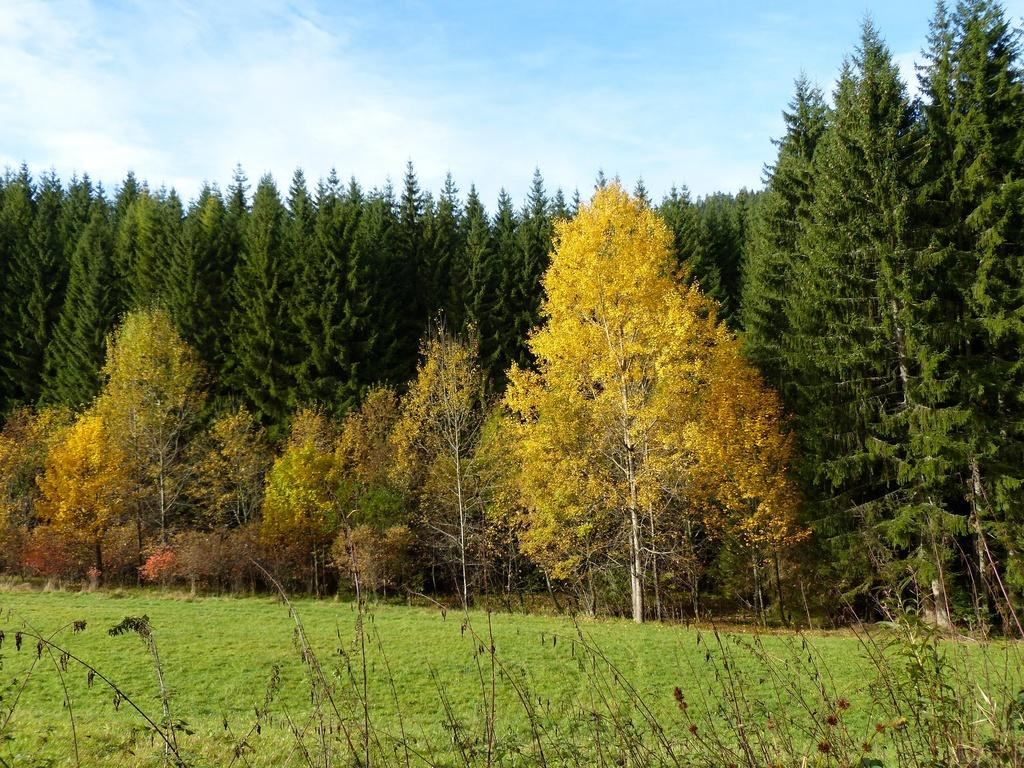What type of vegetation can be seen in the image? There are trees in the image. What is on the ground in the image? There is grass on the ground in the image. What is the condition of the sky in the image? The sky is cloudy in the image. How many flowers are visible in the image? There are no flowers visible in the image; it features trees and grass. What type of animal is pulling a cart in the image? There is no animal pulling a cart in the image. 